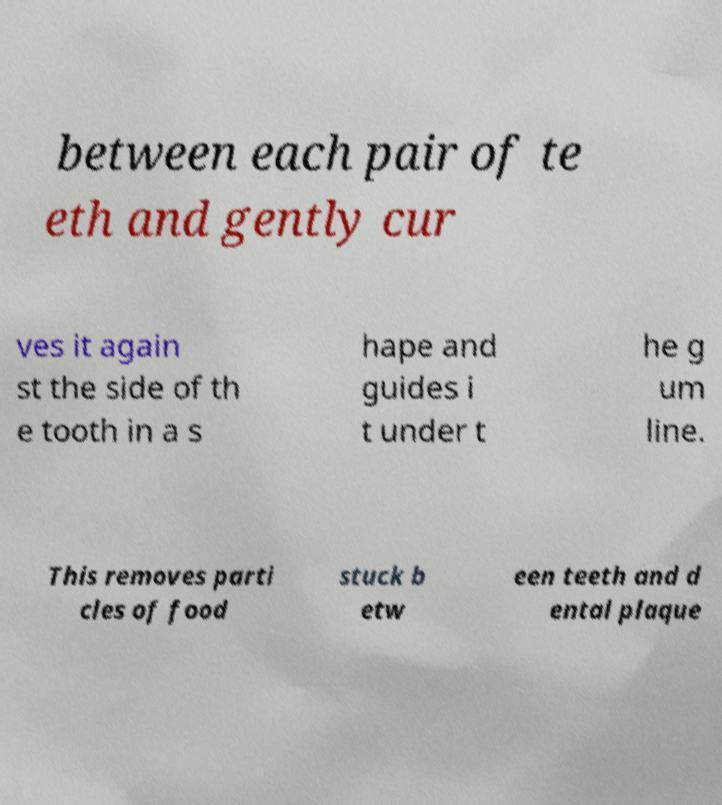Please read and relay the text visible in this image. What does it say? between each pair of te eth and gently cur ves it again st the side of th e tooth in a s hape and guides i t under t he g um line. This removes parti cles of food stuck b etw een teeth and d ental plaque 